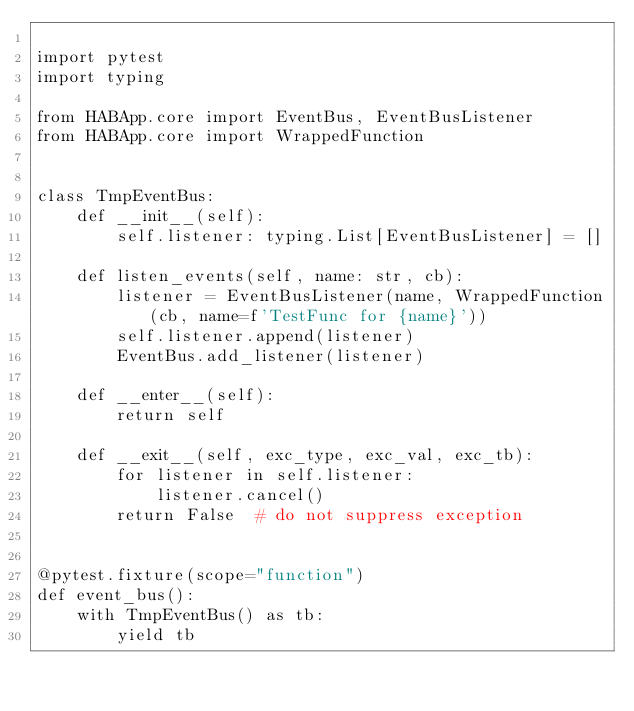Convert code to text. <code><loc_0><loc_0><loc_500><loc_500><_Python_>
import pytest
import typing

from HABApp.core import EventBus, EventBusListener
from HABApp.core import WrappedFunction


class TmpEventBus:
    def __init__(self):
        self.listener: typing.List[EventBusListener] = []

    def listen_events(self, name: str, cb):
        listener = EventBusListener(name, WrappedFunction(cb, name=f'TestFunc for {name}'))
        self.listener.append(listener)
        EventBus.add_listener(listener)

    def __enter__(self):
        return self

    def __exit__(self, exc_type, exc_val, exc_tb):
        for listener in self.listener:
            listener.cancel()
        return False  # do not suppress exception


@pytest.fixture(scope="function")
def event_bus():
    with TmpEventBus() as tb:
        yield tb
</code> 